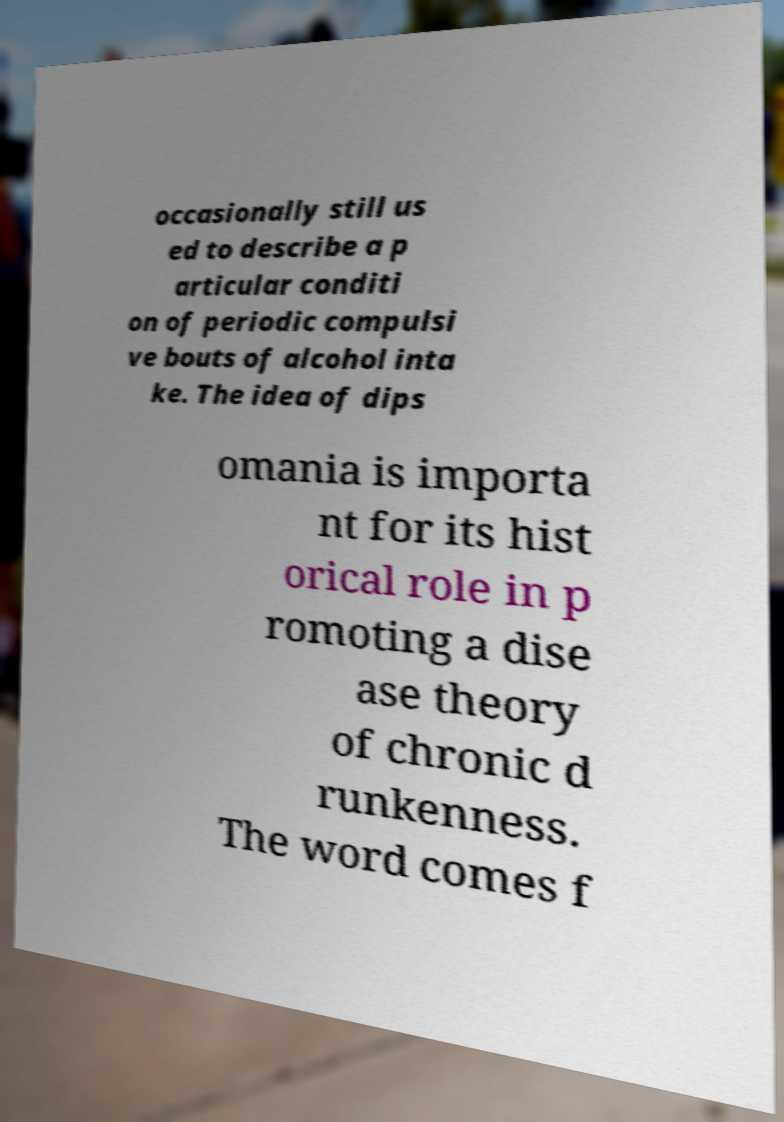Can you accurately transcribe the text from the provided image for me? occasionally still us ed to describe a p articular conditi on of periodic compulsi ve bouts of alcohol inta ke. The idea of dips omania is importa nt for its hist orical role in p romoting a dise ase theory of chronic d runkenness. The word comes f 